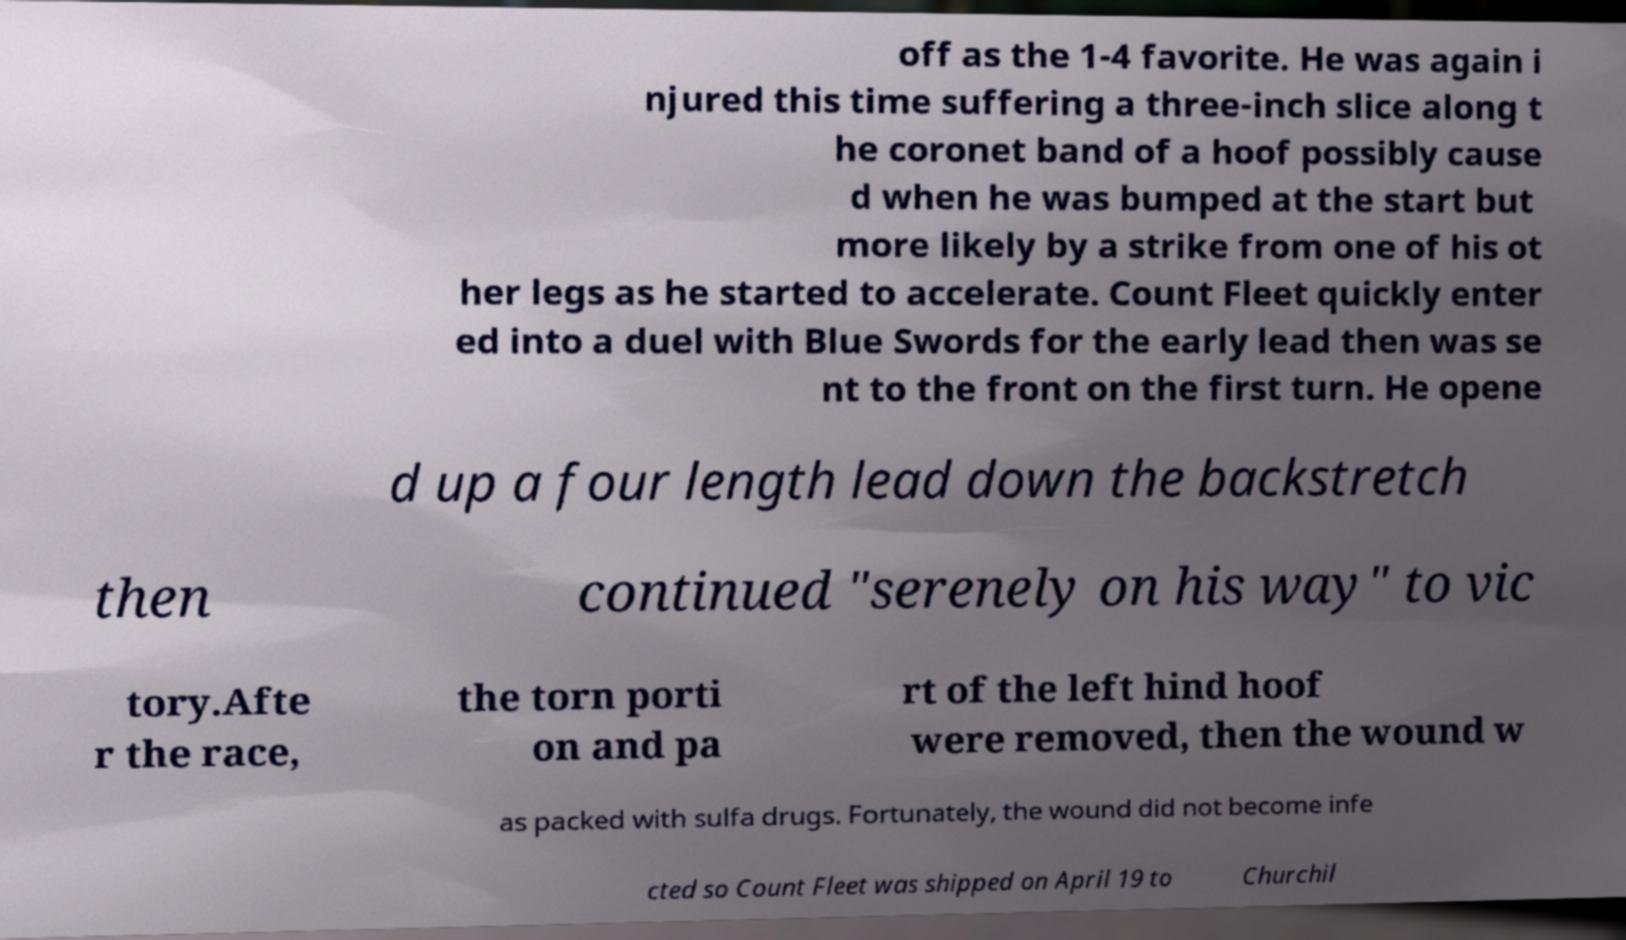Please identify and transcribe the text found in this image. off as the 1-4 favorite. He was again i njured this time suffering a three-inch slice along t he coronet band of a hoof possibly cause d when he was bumped at the start but more likely by a strike from one of his ot her legs as he started to accelerate. Count Fleet quickly enter ed into a duel with Blue Swords for the early lead then was se nt to the front on the first turn. He opene d up a four length lead down the backstretch then continued "serenely on his way" to vic tory.Afte r the race, the torn porti on and pa rt of the left hind hoof were removed, then the wound w as packed with sulfa drugs. Fortunately, the wound did not become infe cted so Count Fleet was shipped on April 19 to Churchil 